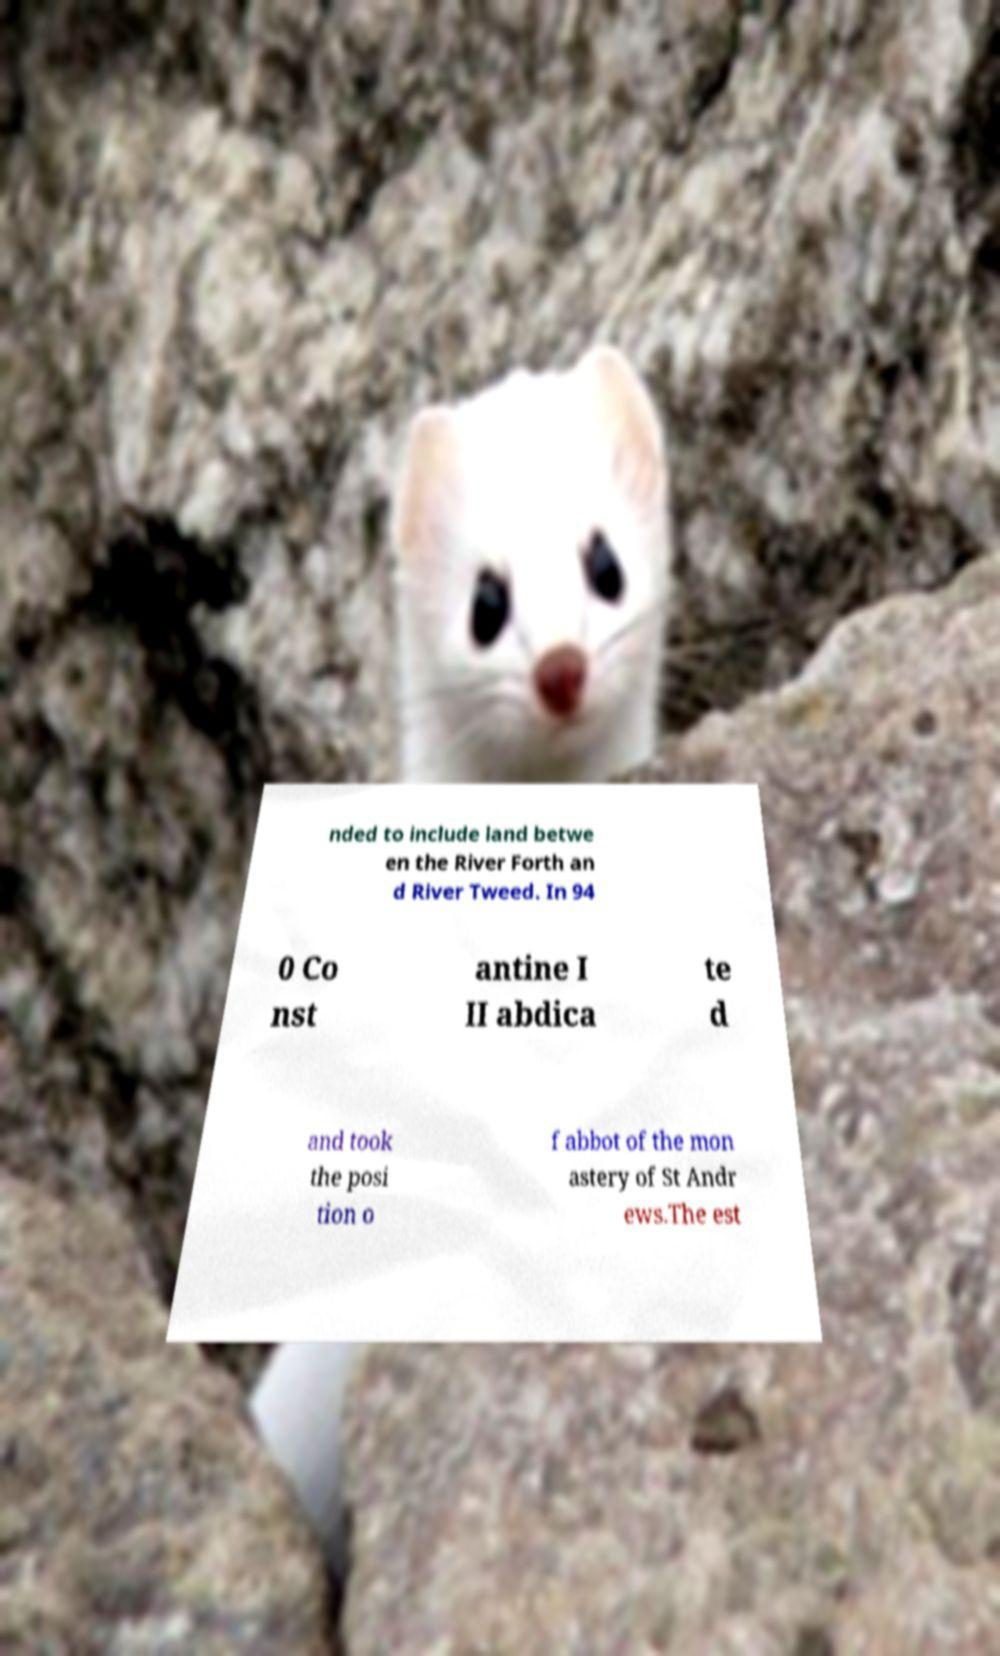I need the written content from this picture converted into text. Can you do that? nded to include land betwe en the River Forth an d River Tweed. In 94 0 Co nst antine I II abdica te d and took the posi tion o f abbot of the mon astery of St Andr ews.The est 